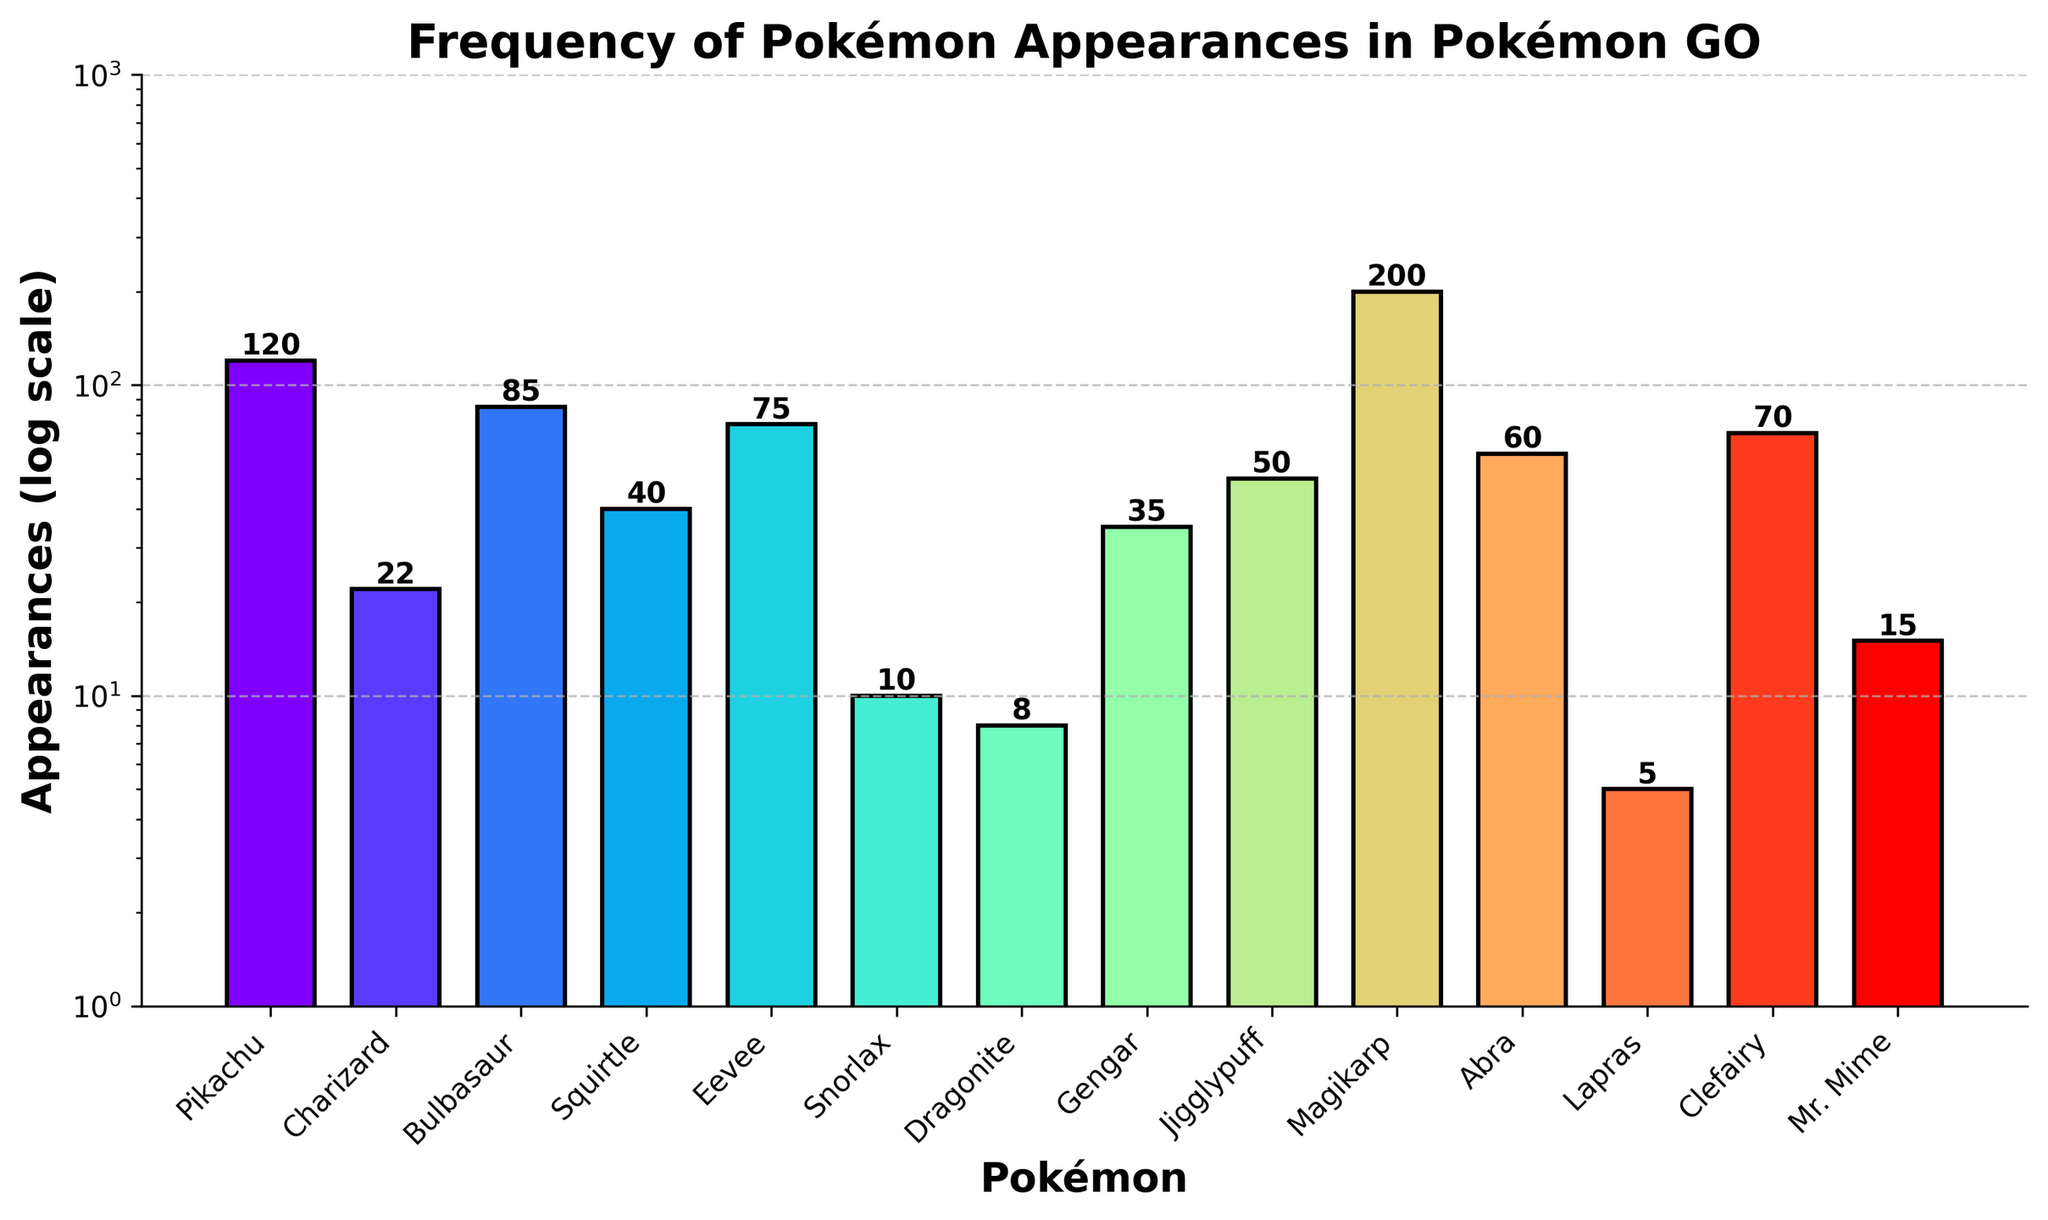Which Pokémon has the highest number of appearances? Look at the tallest bar in the plot. The Pokémon with the highest bar has the most appearances.
Answer: Magikarp Which Pokémon has the least appearance? Look for the shortest bar in the plot. The Pokémon with the shortest bar has the least appearances.
Answer: Lapras How many Pokémon have more than 50 appearances? Count the number of bars taller than the line representing 50 appearances on the y-axis.
Answer: 6 If you combine the appearances of Charizard and Dragonite, what is the total? Find the bar height (frequency) of Charizard and Dragonite. Add their values together: 22 (Charizard) + 8 (Dragonite) = 30
Answer: 30 Which Pokémon have between 20 and 40 appearances? Look at the bars between the lines for 20 and 40 on the y-axis and list the corresponding Pokémon names.
Answer: Charizard, Squirtle, Gengar Are there more Pokémon with less than 15 appearances or with more than 70 appearances? Count the bars below the 15 line and above the 70 line. Compare the numbers. Less than 15: Snorlax, Dragonite, Lapras, Mr. Mime (4), More than 70: Pikachu, Bulbasaur, Eevee, Magikarp, Clefairy (5).
Answer: More Pokémon have more than 70 appearances What is the average number of appearances for all the Pokémon? Sum all the appearance numbers (120+22+85+40+75+10+8+35+50+200+60+5+70+15=795) and divide by the number of Pokémon (14). 795 / 14 ≈ 56.8
Answer: 56.8 How many Pokémon have appearances logged on a log scale between 10 and 100? Count the bars that fall between 10 and 100 on the y-axis log scale.
Answer: 6 Which Pokémon has exactly 75 appearances? Look for the bar labeled with 75 on top in the plot.
Answer: Eevee What is the difference in appearances between Pikachu and Snorlax? Subtract the appearance number of Snorlax from Pikachu's: 120 - 10 = 110
Answer: 110 